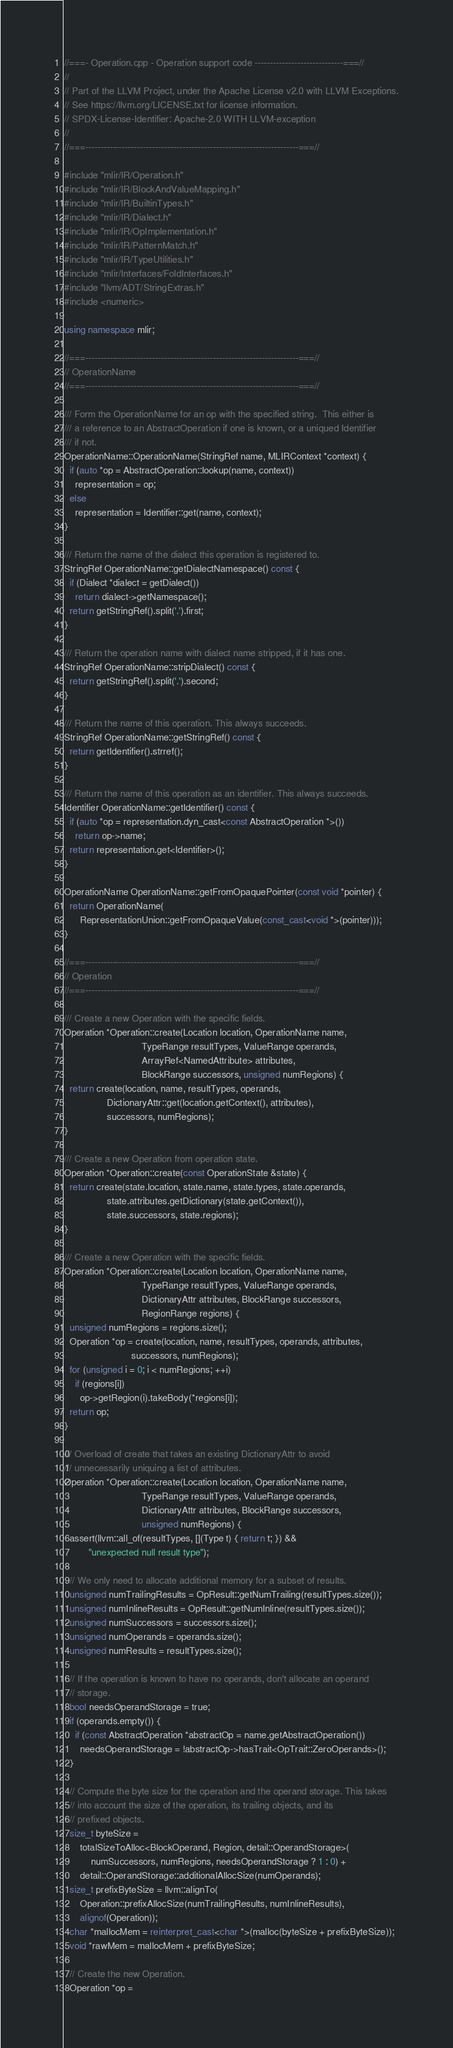<code> <loc_0><loc_0><loc_500><loc_500><_C++_>//===- Operation.cpp - Operation support code -----------------------------===//
//
// Part of the LLVM Project, under the Apache License v2.0 with LLVM Exceptions.
// See https://llvm.org/LICENSE.txt for license information.
// SPDX-License-Identifier: Apache-2.0 WITH LLVM-exception
//
//===----------------------------------------------------------------------===//

#include "mlir/IR/Operation.h"
#include "mlir/IR/BlockAndValueMapping.h"
#include "mlir/IR/BuiltinTypes.h"
#include "mlir/IR/Dialect.h"
#include "mlir/IR/OpImplementation.h"
#include "mlir/IR/PatternMatch.h"
#include "mlir/IR/TypeUtilities.h"
#include "mlir/Interfaces/FoldInterfaces.h"
#include "llvm/ADT/StringExtras.h"
#include <numeric>

using namespace mlir;

//===----------------------------------------------------------------------===//
// OperationName
//===----------------------------------------------------------------------===//

/// Form the OperationName for an op with the specified string.  This either is
/// a reference to an AbstractOperation if one is known, or a uniqued Identifier
/// if not.
OperationName::OperationName(StringRef name, MLIRContext *context) {
  if (auto *op = AbstractOperation::lookup(name, context))
    representation = op;
  else
    representation = Identifier::get(name, context);
}

/// Return the name of the dialect this operation is registered to.
StringRef OperationName::getDialectNamespace() const {
  if (Dialect *dialect = getDialect())
    return dialect->getNamespace();
  return getStringRef().split('.').first;
}

/// Return the operation name with dialect name stripped, if it has one.
StringRef OperationName::stripDialect() const {
  return getStringRef().split('.').second;
}

/// Return the name of this operation. This always succeeds.
StringRef OperationName::getStringRef() const {
  return getIdentifier().strref();
}

/// Return the name of this operation as an identifier. This always succeeds.
Identifier OperationName::getIdentifier() const {
  if (auto *op = representation.dyn_cast<const AbstractOperation *>())
    return op->name;
  return representation.get<Identifier>();
}

OperationName OperationName::getFromOpaquePointer(const void *pointer) {
  return OperationName(
      RepresentationUnion::getFromOpaqueValue(const_cast<void *>(pointer)));
}

//===----------------------------------------------------------------------===//
// Operation
//===----------------------------------------------------------------------===//

/// Create a new Operation with the specific fields.
Operation *Operation::create(Location location, OperationName name,
                             TypeRange resultTypes, ValueRange operands,
                             ArrayRef<NamedAttribute> attributes,
                             BlockRange successors, unsigned numRegions) {
  return create(location, name, resultTypes, operands,
                DictionaryAttr::get(location.getContext(), attributes),
                successors, numRegions);
}

/// Create a new Operation from operation state.
Operation *Operation::create(const OperationState &state) {
  return create(state.location, state.name, state.types, state.operands,
                state.attributes.getDictionary(state.getContext()),
                state.successors, state.regions);
}

/// Create a new Operation with the specific fields.
Operation *Operation::create(Location location, OperationName name,
                             TypeRange resultTypes, ValueRange operands,
                             DictionaryAttr attributes, BlockRange successors,
                             RegionRange regions) {
  unsigned numRegions = regions.size();
  Operation *op = create(location, name, resultTypes, operands, attributes,
                         successors, numRegions);
  for (unsigned i = 0; i < numRegions; ++i)
    if (regions[i])
      op->getRegion(i).takeBody(*regions[i]);
  return op;
}

/// Overload of create that takes an existing DictionaryAttr to avoid
/// unnecessarily uniquing a list of attributes.
Operation *Operation::create(Location location, OperationName name,
                             TypeRange resultTypes, ValueRange operands,
                             DictionaryAttr attributes, BlockRange successors,
                             unsigned numRegions) {
  assert(llvm::all_of(resultTypes, [](Type t) { return t; }) &&
         "unexpected null result type");

  // We only need to allocate additional memory for a subset of results.
  unsigned numTrailingResults = OpResult::getNumTrailing(resultTypes.size());
  unsigned numInlineResults = OpResult::getNumInline(resultTypes.size());
  unsigned numSuccessors = successors.size();
  unsigned numOperands = operands.size();
  unsigned numResults = resultTypes.size();

  // If the operation is known to have no operands, don't allocate an operand
  // storage.
  bool needsOperandStorage = true;
  if (operands.empty()) {
    if (const AbstractOperation *abstractOp = name.getAbstractOperation())
      needsOperandStorage = !abstractOp->hasTrait<OpTrait::ZeroOperands>();
  }

  // Compute the byte size for the operation and the operand storage. This takes
  // into account the size of the operation, its trailing objects, and its
  // prefixed objects.
  size_t byteSize =
      totalSizeToAlloc<BlockOperand, Region, detail::OperandStorage>(
          numSuccessors, numRegions, needsOperandStorage ? 1 : 0) +
      detail::OperandStorage::additionalAllocSize(numOperands);
  size_t prefixByteSize = llvm::alignTo(
      Operation::prefixAllocSize(numTrailingResults, numInlineResults),
      alignof(Operation));
  char *mallocMem = reinterpret_cast<char *>(malloc(byteSize + prefixByteSize));
  void *rawMem = mallocMem + prefixByteSize;

  // Create the new Operation.
  Operation *op =</code> 